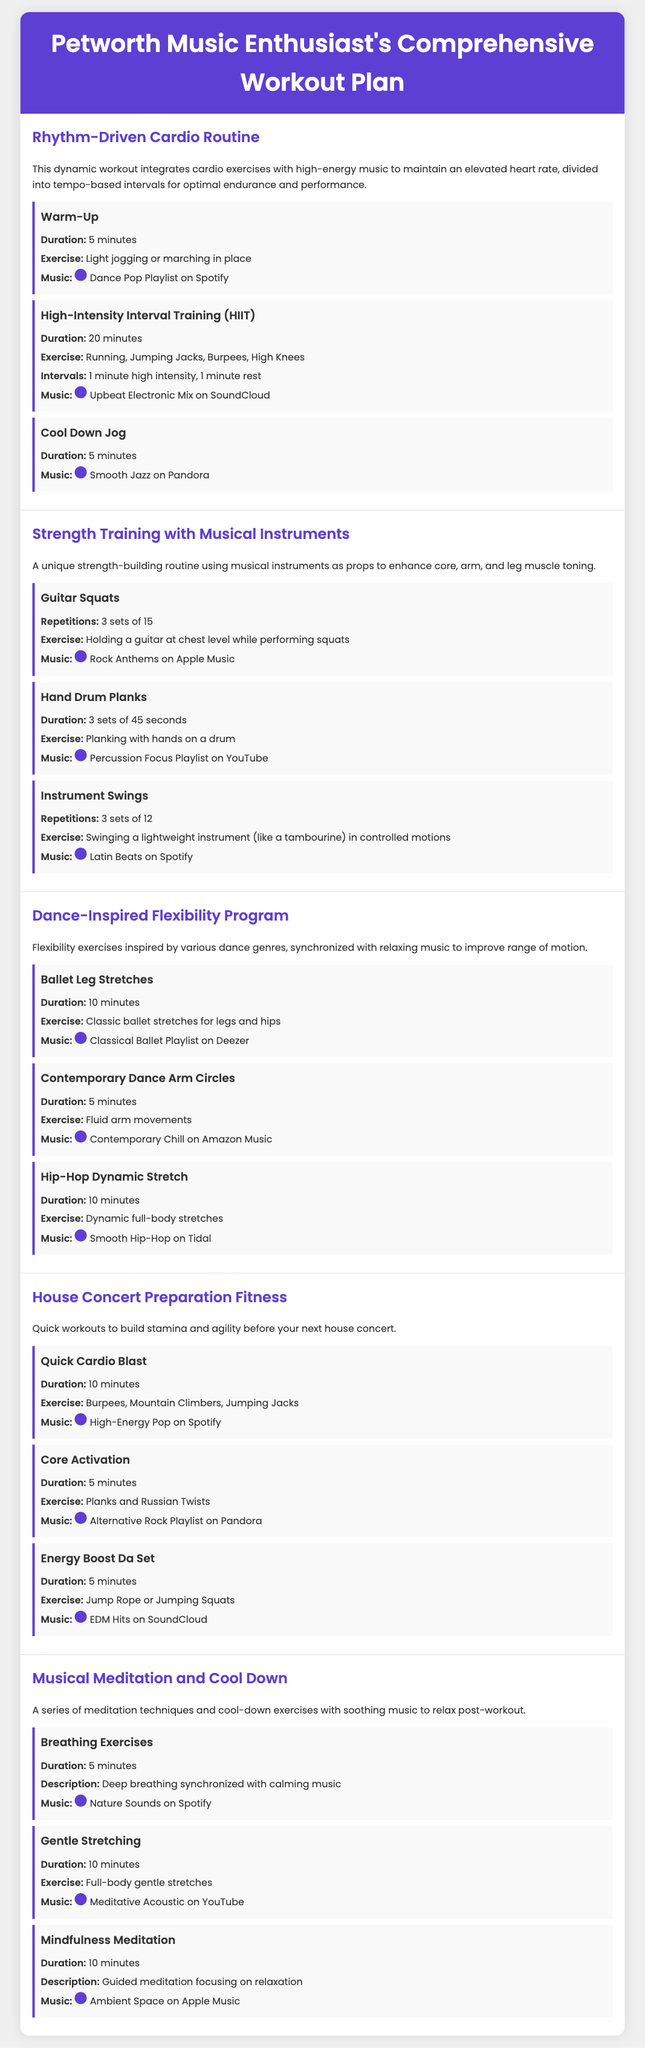What is the duration of the warm-up in the Rhythm-Driven Cardio Routine? The warm-up duration is specified as 5 minutes in the document.
Answer: 5 minutes How many sets are required for Instrument Swings? The document states that Instrument Swings require 3 sets of 12 repetitions.
Answer: 3 sets of 12 What type of music is suggested for the House Concert Preparation Fitness Quick Cardio Blast? The document mentions High-Energy Pop on Spotify for this activity.
Answer: High-Energy Pop on Spotify What is the main focus of the Strength Training with Musical Instruments section? The focus is on using musical instruments as props for strength-building exercises.
Answer: Strength-building with musical instruments How long is the duration for the Mindfulness Meditation? The document lists the duration for Mindfulness Meditation as 10 minutes.
Answer: 10 minutes What exercises are included in the High-Intensity Interval Training? The HIIT section includes Running, Jumping Jacks, Burpees, and High Knees.
Answer: Running, Jumping Jacks, Burpees, High Knees What kind of workout does the Dance-Inspired Flexibility Program provide? The program offers a series of stretching and flexibility exercises inspired by various dance genres.
Answer: Stretching and flexibility exercises Which playlist is suggested for Gentle Stretching? The document suggests Meditative Acoustic on YouTube for Gentle Stretching.
Answer: Meditative Acoustic on YouTube What is the main outcome desired from the House Concert Preparation Fitness? The outcome is to build stamina and agility before attending house concerts.
Answer: Build stamina and agility 